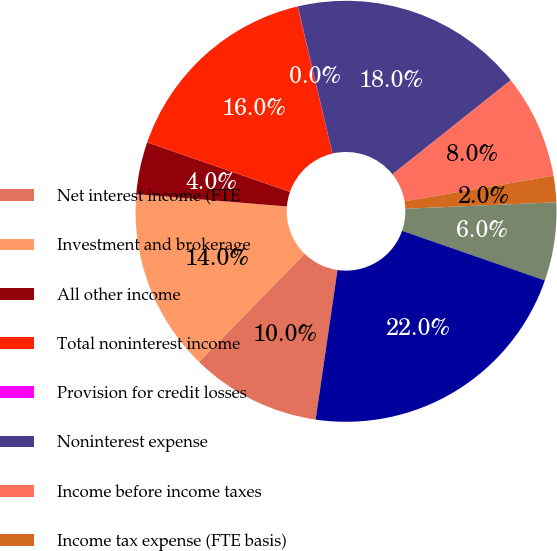Convert chart. <chart><loc_0><loc_0><loc_500><loc_500><pie_chart><fcel>Net interest income (FTE<fcel>Investment and brokerage<fcel>All other income<fcel>Total noninterest income<fcel>Provision for credit losses<fcel>Noninterest expense<fcel>Income before income taxes<fcel>Income tax expense (FTE basis)<fcel>Net income<fcel>Total loans and leases<nl><fcel>10.0%<fcel>13.99%<fcel>4.01%<fcel>15.99%<fcel>0.02%<fcel>17.98%<fcel>8.0%<fcel>2.02%<fcel>6.01%<fcel>21.98%<nl></chart> 